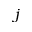<formula> <loc_0><loc_0><loc_500><loc_500>j</formula> 